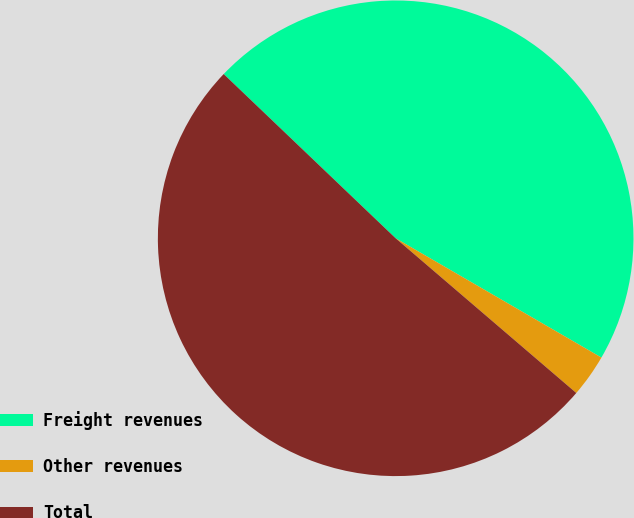<chart> <loc_0><loc_0><loc_500><loc_500><pie_chart><fcel>Freight revenues<fcel>Other revenues<fcel>Total<nl><fcel>46.23%<fcel>2.91%<fcel>50.86%<nl></chart> 